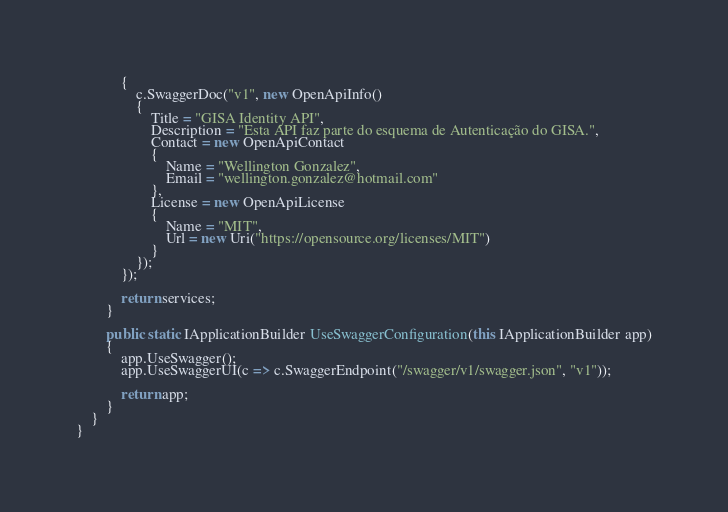Convert code to text. <code><loc_0><loc_0><loc_500><loc_500><_C#_>            {
                c.SwaggerDoc("v1", new OpenApiInfo()
                {
                    Title = "GISA Identity API",
                    Description = "Esta API faz parte do esquema de Autenticação do GISA.",
                    Contact = new OpenApiContact
                    {
                        Name = "Wellington Gonzalez",
                        Email = "wellington.gonzalez@hotmail.com"
                    },
                    License = new OpenApiLicense
                    {
                        Name = "MIT",
                        Url = new Uri("https://opensource.org/licenses/MIT")
                    }
                });
            });

            return services;
        }

        public static IApplicationBuilder UseSwaggerConfiguration(this IApplicationBuilder app)
        {
            app.UseSwagger();
            app.UseSwaggerUI(c => c.SwaggerEndpoint("/swagger/v1/swagger.json", "v1"));

            return app;
        }
    }
}</code> 